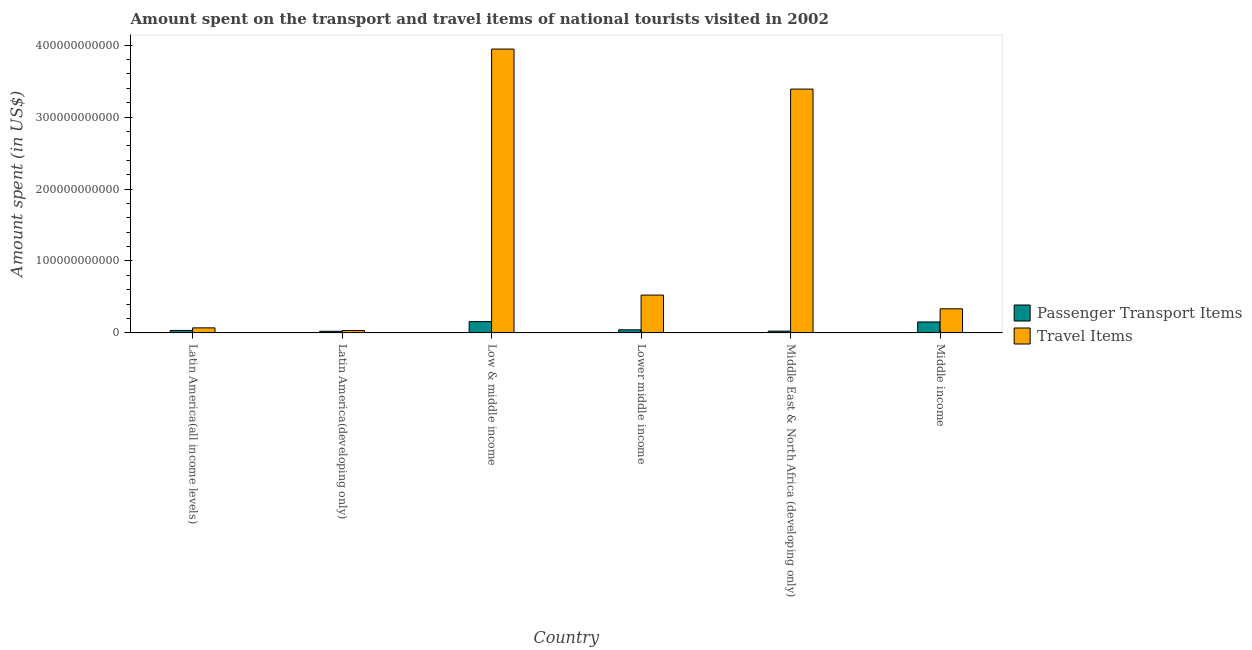How many groups of bars are there?
Your response must be concise. 6. Are the number of bars per tick equal to the number of legend labels?
Make the answer very short. Yes. Are the number of bars on each tick of the X-axis equal?
Offer a very short reply. Yes. How many bars are there on the 1st tick from the right?
Keep it short and to the point. 2. What is the label of the 5th group of bars from the left?
Your answer should be very brief. Middle East & North Africa (developing only). What is the amount spent in travel items in Middle income?
Your answer should be very brief. 3.35e+1. Across all countries, what is the maximum amount spent in travel items?
Offer a very short reply. 3.94e+11. Across all countries, what is the minimum amount spent on passenger transport items?
Provide a short and direct response. 2.32e+09. In which country was the amount spent on passenger transport items maximum?
Ensure brevity in your answer.  Low & middle income. In which country was the amount spent on passenger transport items minimum?
Make the answer very short. Latin America(developing only). What is the total amount spent on passenger transport items in the graph?
Offer a terse response. 4.37e+1. What is the difference between the amount spent in travel items in Low & middle income and that in Middle East & North Africa (developing only)?
Offer a very short reply. 5.56e+1. What is the difference between the amount spent on passenger transport items in Latin America(developing only) and the amount spent in travel items in Middle East & North Africa (developing only)?
Your answer should be very brief. -3.37e+11. What is the average amount spent in travel items per country?
Make the answer very short. 1.38e+11. What is the difference between the amount spent in travel items and amount spent on passenger transport items in Middle East & North Africa (developing only)?
Provide a short and direct response. 3.36e+11. What is the ratio of the amount spent on passenger transport items in Latin America(all income levels) to that in Middle East & North Africa (developing only)?
Give a very brief answer. 1.38. Is the amount spent in travel items in Low & middle income less than that in Lower middle income?
Provide a short and direct response. No. Is the difference between the amount spent on passenger transport items in Latin America(all income levels) and Lower middle income greater than the difference between the amount spent in travel items in Latin America(all income levels) and Lower middle income?
Provide a succinct answer. Yes. What is the difference between the highest and the second highest amount spent in travel items?
Keep it short and to the point. 5.56e+1. What is the difference between the highest and the lowest amount spent on passenger transport items?
Your response must be concise. 1.34e+1. In how many countries, is the amount spent on passenger transport items greater than the average amount spent on passenger transport items taken over all countries?
Offer a terse response. 2. What does the 1st bar from the left in Middle East & North Africa (developing only) represents?
Your response must be concise. Passenger Transport Items. What does the 1st bar from the right in Lower middle income represents?
Your answer should be very brief. Travel Items. How many bars are there?
Your answer should be very brief. 12. What is the difference between two consecutive major ticks on the Y-axis?
Offer a terse response. 1.00e+11. Are the values on the major ticks of Y-axis written in scientific E-notation?
Your answer should be very brief. No. Does the graph contain grids?
Your answer should be very brief. No. How are the legend labels stacked?
Keep it short and to the point. Vertical. What is the title of the graph?
Your answer should be very brief. Amount spent on the transport and travel items of national tourists visited in 2002. What is the label or title of the Y-axis?
Offer a very short reply. Amount spent (in US$). What is the Amount spent (in US$) of Passenger Transport Items in Latin America(all income levels)?
Your answer should be very brief. 3.48e+09. What is the Amount spent (in US$) of Travel Items in Latin America(all income levels)?
Your answer should be compact. 7.04e+09. What is the Amount spent (in US$) in Passenger Transport Items in Latin America(developing only)?
Ensure brevity in your answer.  2.32e+09. What is the Amount spent (in US$) in Travel Items in Latin America(developing only)?
Ensure brevity in your answer.  3.36e+09. What is the Amount spent (in US$) in Passenger Transport Items in Low & middle income?
Your answer should be very brief. 1.58e+1. What is the Amount spent (in US$) in Travel Items in Low & middle income?
Your answer should be very brief. 3.94e+11. What is the Amount spent (in US$) in Passenger Transport Items in Lower middle income?
Offer a very short reply. 4.34e+09. What is the Amount spent (in US$) of Travel Items in Lower middle income?
Your answer should be very brief. 5.26e+1. What is the Amount spent (in US$) in Passenger Transport Items in Middle East & North Africa (developing only)?
Give a very brief answer. 2.53e+09. What is the Amount spent (in US$) of Travel Items in Middle East & North Africa (developing only)?
Your response must be concise. 3.39e+11. What is the Amount spent (in US$) of Passenger Transport Items in Middle income?
Offer a terse response. 1.53e+1. What is the Amount spent (in US$) of Travel Items in Middle income?
Your answer should be compact. 3.35e+1. Across all countries, what is the maximum Amount spent (in US$) of Passenger Transport Items?
Offer a terse response. 1.58e+1. Across all countries, what is the maximum Amount spent (in US$) in Travel Items?
Give a very brief answer. 3.94e+11. Across all countries, what is the minimum Amount spent (in US$) in Passenger Transport Items?
Your answer should be compact. 2.32e+09. Across all countries, what is the minimum Amount spent (in US$) of Travel Items?
Ensure brevity in your answer.  3.36e+09. What is the total Amount spent (in US$) of Passenger Transport Items in the graph?
Provide a succinct answer. 4.37e+1. What is the total Amount spent (in US$) in Travel Items in the graph?
Your answer should be very brief. 8.30e+11. What is the difference between the Amount spent (in US$) in Passenger Transport Items in Latin America(all income levels) and that in Latin America(developing only)?
Your answer should be very brief. 1.16e+09. What is the difference between the Amount spent (in US$) of Travel Items in Latin America(all income levels) and that in Latin America(developing only)?
Keep it short and to the point. 3.68e+09. What is the difference between the Amount spent (in US$) of Passenger Transport Items in Latin America(all income levels) and that in Low & middle income?
Provide a succinct answer. -1.23e+1. What is the difference between the Amount spent (in US$) in Travel Items in Latin America(all income levels) and that in Low & middle income?
Give a very brief answer. -3.87e+11. What is the difference between the Amount spent (in US$) in Passenger Transport Items in Latin America(all income levels) and that in Lower middle income?
Give a very brief answer. -8.53e+08. What is the difference between the Amount spent (in US$) of Travel Items in Latin America(all income levels) and that in Lower middle income?
Ensure brevity in your answer.  -4.55e+1. What is the difference between the Amount spent (in US$) in Passenger Transport Items in Latin America(all income levels) and that in Middle East & North Africa (developing only)?
Your answer should be very brief. 9.56e+08. What is the difference between the Amount spent (in US$) in Travel Items in Latin America(all income levels) and that in Middle East & North Africa (developing only)?
Make the answer very short. -3.32e+11. What is the difference between the Amount spent (in US$) in Passenger Transport Items in Latin America(all income levels) and that in Middle income?
Make the answer very short. -1.18e+1. What is the difference between the Amount spent (in US$) in Travel Items in Latin America(all income levels) and that in Middle income?
Offer a terse response. -2.65e+1. What is the difference between the Amount spent (in US$) of Passenger Transport Items in Latin America(developing only) and that in Low & middle income?
Give a very brief answer. -1.34e+1. What is the difference between the Amount spent (in US$) in Travel Items in Latin America(developing only) and that in Low & middle income?
Provide a short and direct response. -3.91e+11. What is the difference between the Amount spent (in US$) of Passenger Transport Items in Latin America(developing only) and that in Lower middle income?
Make the answer very short. -2.01e+09. What is the difference between the Amount spent (in US$) in Travel Items in Latin America(developing only) and that in Lower middle income?
Provide a short and direct response. -4.92e+1. What is the difference between the Amount spent (in US$) of Passenger Transport Items in Latin America(developing only) and that in Middle East & North Africa (developing only)?
Keep it short and to the point. -2.04e+08. What is the difference between the Amount spent (in US$) of Travel Items in Latin America(developing only) and that in Middle East & North Africa (developing only)?
Give a very brief answer. -3.35e+11. What is the difference between the Amount spent (in US$) in Passenger Transport Items in Latin America(developing only) and that in Middle income?
Your response must be concise. -1.30e+1. What is the difference between the Amount spent (in US$) in Travel Items in Latin America(developing only) and that in Middle income?
Your answer should be compact. -3.02e+1. What is the difference between the Amount spent (in US$) of Passenger Transport Items in Low & middle income and that in Lower middle income?
Give a very brief answer. 1.14e+1. What is the difference between the Amount spent (in US$) of Travel Items in Low & middle income and that in Lower middle income?
Your answer should be compact. 3.42e+11. What is the difference between the Amount spent (in US$) in Passenger Transport Items in Low & middle income and that in Middle East & North Africa (developing only)?
Keep it short and to the point. 1.32e+1. What is the difference between the Amount spent (in US$) in Travel Items in Low & middle income and that in Middle East & North Africa (developing only)?
Your response must be concise. 5.56e+1. What is the difference between the Amount spent (in US$) of Passenger Transport Items in Low & middle income and that in Middle income?
Give a very brief answer. 4.68e+08. What is the difference between the Amount spent (in US$) in Travel Items in Low & middle income and that in Middle income?
Your response must be concise. 3.61e+11. What is the difference between the Amount spent (in US$) of Passenger Transport Items in Lower middle income and that in Middle East & North Africa (developing only)?
Your answer should be very brief. 1.81e+09. What is the difference between the Amount spent (in US$) of Travel Items in Lower middle income and that in Middle East & North Africa (developing only)?
Make the answer very short. -2.86e+11. What is the difference between the Amount spent (in US$) of Passenger Transport Items in Lower middle income and that in Middle income?
Make the answer very short. -1.10e+1. What is the difference between the Amount spent (in US$) in Travel Items in Lower middle income and that in Middle income?
Keep it short and to the point. 1.91e+1. What is the difference between the Amount spent (in US$) of Passenger Transport Items in Middle East & North Africa (developing only) and that in Middle income?
Keep it short and to the point. -1.28e+1. What is the difference between the Amount spent (in US$) in Travel Items in Middle East & North Africa (developing only) and that in Middle income?
Offer a terse response. 3.05e+11. What is the difference between the Amount spent (in US$) in Passenger Transport Items in Latin America(all income levels) and the Amount spent (in US$) in Travel Items in Latin America(developing only)?
Your response must be concise. 1.20e+08. What is the difference between the Amount spent (in US$) in Passenger Transport Items in Latin America(all income levels) and the Amount spent (in US$) in Travel Items in Low & middle income?
Offer a very short reply. -3.91e+11. What is the difference between the Amount spent (in US$) of Passenger Transport Items in Latin America(all income levels) and the Amount spent (in US$) of Travel Items in Lower middle income?
Your answer should be compact. -4.91e+1. What is the difference between the Amount spent (in US$) of Passenger Transport Items in Latin America(all income levels) and the Amount spent (in US$) of Travel Items in Middle East & North Africa (developing only)?
Offer a very short reply. -3.35e+11. What is the difference between the Amount spent (in US$) of Passenger Transport Items in Latin America(all income levels) and the Amount spent (in US$) of Travel Items in Middle income?
Your answer should be very brief. -3.00e+1. What is the difference between the Amount spent (in US$) in Passenger Transport Items in Latin America(developing only) and the Amount spent (in US$) in Travel Items in Low & middle income?
Your response must be concise. -3.92e+11. What is the difference between the Amount spent (in US$) in Passenger Transport Items in Latin America(developing only) and the Amount spent (in US$) in Travel Items in Lower middle income?
Offer a terse response. -5.03e+1. What is the difference between the Amount spent (in US$) of Passenger Transport Items in Latin America(developing only) and the Amount spent (in US$) of Travel Items in Middle East & North Africa (developing only)?
Give a very brief answer. -3.37e+11. What is the difference between the Amount spent (in US$) of Passenger Transport Items in Latin America(developing only) and the Amount spent (in US$) of Travel Items in Middle income?
Provide a succinct answer. -3.12e+1. What is the difference between the Amount spent (in US$) of Passenger Transport Items in Low & middle income and the Amount spent (in US$) of Travel Items in Lower middle income?
Offer a very short reply. -3.68e+1. What is the difference between the Amount spent (in US$) of Passenger Transport Items in Low & middle income and the Amount spent (in US$) of Travel Items in Middle East & North Africa (developing only)?
Offer a very short reply. -3.23e+11. What is the difference between the Amount spent (in US$) in Passenger Transport Items in Low & middle income and the Amount spent (in US$) in Travel Items in Middle income?
Offer a terse response. -1.78e+1. What is the difference between the Amount spent (in US$) of Passenger Transport Items in Lower middle income and the Amount spent (in US$) of Travel Items in Middle East & North Africa (developing only)?
Your answer should be very brief. -3.34e+11. What is the difference between the Amount spent (in US$) in Passenger Transport Items in Lower middle income and the Amount spent (in US$) in Travel Items in Middle income?
Keep it short and to the point. -2.92e+1. What is the difference between the Amount spent (in US$) of Passenger Transport Items in Middle East & North Africa (developing only) and the Amount spent (in US$) of Travel Items in Middle income?
Ensure brevity in your answer.  -3.10e+1. What is the average Amount spent (in US$) in Passenger Transport Items per country?
Give a very brief answer. 7.29e+09. What is the average Amount spent (in US$) in Travel Items per country?
Make the answer very short. 1.38e+11. What is the difference between the Amount spent (in US$) in Passenger Transport Items and Amount spent (in US$) in Travel Items in Latin America(all income levels)?
Offer a very short reply. -3.56e+09. What is the difference between the Amount spent (in US$) in Passenger Transport Items and Amount spent (in US$) in Travel Items in Latin America(developing only)?
Provide a succinct answer. -1.04e+09. What is the difference between the Amount spent (in US$) in Passenger Transport Items and Amount spent (in US$) in Travel Items in Low & middle income?
Ensure brevity in your answer.  -3.79e+11. What is the difference between the Amount spent (in US$) of Passenger Transport Items and Amount spent (in US$) of Travel Items in Lower middle income?
Provide a short and direct response. -4.83e+1. What is the difference between the Amount spent (in US$) of Passenger Transport Items and Amount spent (in US$) of Travel Items in Middle East & North Africa (developing only)?
Keep it short and to the point. -3.36e+11. What is the difference between the Amount spent (in US$) of Passenger Transport Items and Amount spent (in US$) of Travel Items in Middle income?
Your answer should be very brief. -1.82e+1. What is the ratio of the Amount spent (in US$) in Passenger Transport Items in Latin America(all income levels) to that in Latin America(developing only)?
Ensure brevity in your answer.  1.5. What is the ratio of the Amount spent (in US$) of Travel Items in Latin America(all income levels) to that in Latin America(developing only)?
Ensure brevity in your answer.  2.09. What is the ratio of the Amount spent (in US$) in Passenger Transport Items in Latin America(all income levels) to that in Low & middle income?
Your answer should be very brief. 0.22. What is the ratio of the Amount spent (in US$) of Travel Items in Latin America(all income levels) to that in Low & middle income?
Provide a succinct answer. 0.02. What is the ratio of the Amount spent (in US$) in Passenger Transport Items in Latin America(all income levels) to that in Lower middle income?
Offer a terse response. 0.8. What is the ratio of the Amount spent (in US$) of Travel Items in Latin America(all income levels) to that in Lower middle income?
Your answer should be very brief. 0.13. What is the ratio of the Amount spent (in US$) in Passenger Transport Items in Latin America(all income levels) to that in Middle East & North Africa (developing only)?
Provide a succinct answer. 1.38. What is the ratio of the Amount spent (in US$) of Travel Items in Latin America(all income levels) to that in Middle East & North Africa (developing only)?
Keep it short and to the point. 0.02. What is the ratio of the Amount spent (in US$) of Passenger Transport Items in Latin America(all income levels) to that in Middle income?
Your answer should be very brief. 0.23. What is the ratio of the Amount spent (in US$) in Travel Items in Latin America(all income levels) to that in Middle income?
Provide a succinct answer. 0.21. What is the ratio of the Amount spent (in US$) of Passenger Transport Items in Latin America(developing only) to that in Low & middle income?
Your answer should be compact. 0.15. What is the ratio of the Amount spent (in US$) in Travel Items in Latin America(developing only) to that in Low & middle income?
Offer a terse response. 0.01. What is the ratio of the Amount spent (in US$) of Passenger Transport Items in Latin America(developing only) to that in Lower middle income?
Ensure brevity in your answer.  0.54. What is the ratio of the Amount spent (in US$) of Travel Items in Latin America(developing only) to that in Lower middle income?
Your answer should be very brief. 0.06. What is the ratio of the Amount spent (in US$) in Passenger Transport Items in Latin America(developing only) to that in Middle East & North Africa (developing only)?
Your response must be concise. 0.92. What is the ratio of the Amount spent (in US$) in Travel Items in Latin America(developing only) to that in Middle East & North Africa (developing only)?
Ensure brevity in your answer.  0.01. What is the ratio of the Amount spent (in US$) of Passenger Transport Items in Latin America(developing only) to that in Middle income?
Ensure brevity in your answer.  0.15. What is the ratio of the Amount spent (in US$) of Travel Items in Latin America(developing only) to that in Middle income?
Provide a succinct answer. 0.1. What is the ratio of the Amount spent (in US$) in Passenger Transport Items in Low & middle income to that in Lower middle income?
Provide a short and direct response. 3.64. What is the ratio of the Amount spent (in US$) in Travel Items in Low & middle income to that in Lower middle income?
Offer a terse response. 7.5. What is the ratio of the Amount spent (in US$) of Passenger Transport Items in Low & middle income to that in Middle East & North Africa (developing only)?
Make the answer very short. 6.24. What is the ratio of the Amount spent (in US$) of Travel Items in Low & middle income to that in Middle East & North Africa (developing only)?
Offer a very short reply. 1.16. What is the ratio of the Amount spent (in US$) of Passenger Transport Items in Low & middle income to that in Middle income?
Keep it short and to the point. 1.03. What is the ratio of the Amount spent (in US$) of Travel Items in Low & middle income to that in Middle income?
Provide a succinct answer. 11.77. What is the ratio of the Amount spent (in US$) of Passenger Transport Items in Lower middle income to that in Middle East & North Africa (developing only)?
Provide a short and direct response. 1.72. What is the ratio of the Amount spent (in US$) of Travel Items in Lower middle income to that in Middle East & North Africa (developing only)?
Make the answer very short. 0.16. What is the ratio of the Amount spent (in US$) in Passenger Transport Items in Lower middle income to that in Middle income?
Your answer should be compact. 0.28. What is the ratio of the Amount spent (in US$) of Travel Items in Lower middle income to that in Middle income?
Your answer should be compact. 1.57. What is the ratio of the Amount spent (in US$) of Passenger Transport Items in Middle East & North Africa (developing only) to that in Middle income?
Ensure brevity in your answer.  0.17. What is the ratio of the Amount spent (in US$) of Travel Items in Middle East & North Africa (developing only) to that in Middle income?
Your answer should be compact. 10.11. What is the difference between the highest and the second highest Amount spent (in US$) in Passenger Transport Items?
Ensure brevity in your answer.  4.68e+08. What is the difference between the highest and the second highest Amount spent (in US$) of Travel Items?
Provide a short and direct response. 5.56e+1. What is the difference between the highest and the lowest Amount spent (in US$) of Passenger Transport Items?
Provide a short and direct response. 1.34e+1. What is the difference between the highest and the lowest Amount spent (in US$) in Travel Items?
Ensure brevity in your answer.  3.91e+11. 